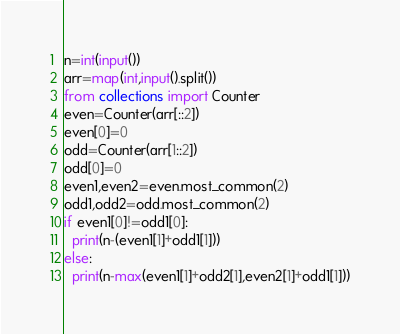Convert code to text. <code><loc_0><loc_0><loc_500><loc_500><_Python_>n=int(input())
arr=map(int,input().split())
from collections import Counter
even=Counter(arr[::2])
even[0]=0
odd=Counter(arr[1::2])
odd[0]=0
even1,even2=even.most_common(2)
odd1,odd2=odd.most_common(2)
if even1[0]!=odd1[0]:
  print(n-(even1[1]+odd1[1]))
else:
  print(n-max(even1[1]+odd2[1],even2[1]+odd1[1]))</code> 